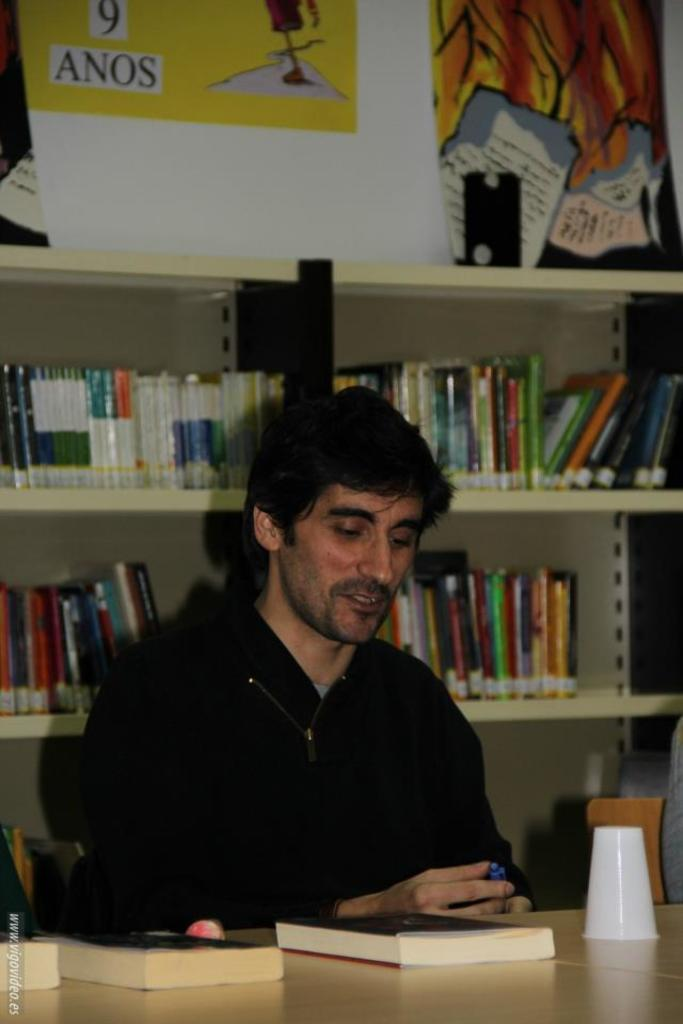Who is present in the image? There is a man in the image. Where is the man located? The man is sitting in a library. What is the man doing in the image? The man is sitting in a library with a book in front of him. What type of glue is the man using to stick the umbrella to the value in the image? There is no glue, umbrella, or value present in the image. 